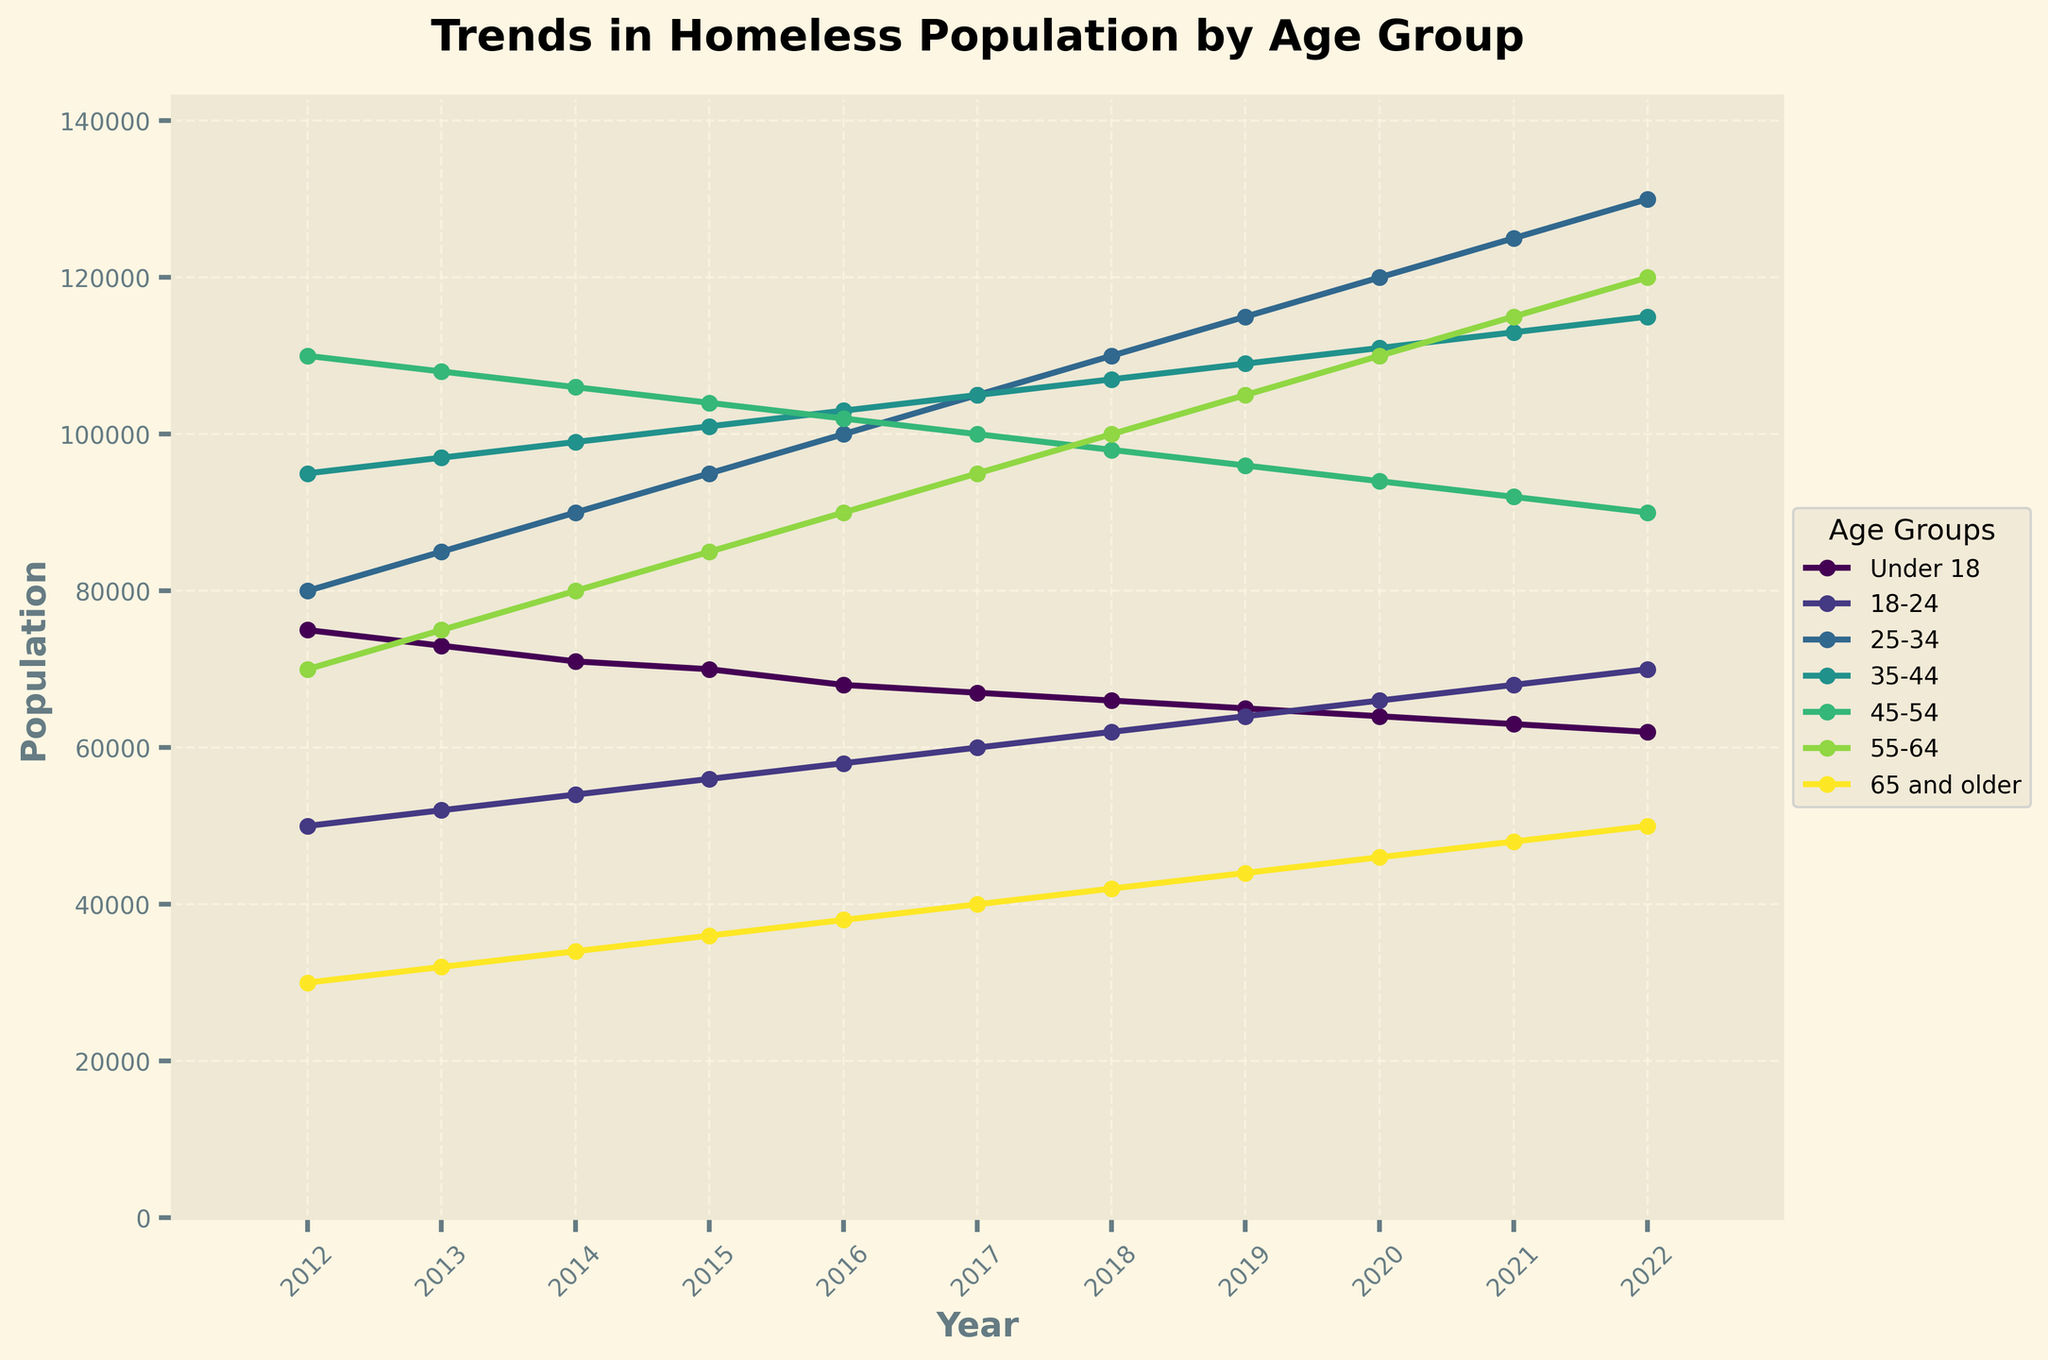What is the general trend in the population of those aged 25-34 over the past decade? The population of those aged 25-34 shows a continuous increase every year. Starting from 80,000 in 2012, it rises annually until it reaches 130,000 in 2022.
Answer: Increasing trend Which age group had the largest initial population in 2012? In 2012, the age group 45-54 had the largest population of 110,000 compared to other age groups.
Answer: 45-54 What is the age group with the highest growth rate from 2012 to 2022? To determine this, calculate the difference for each age group from 2012 to 2022 and spot the highest change. The 25-34 age group increased from 80,000 to 130,000, an increase of 50,000, which is the highest growth among all groups.
Answer: 25-34 Which two age groups crossed each other around 2017? Around the year 2017, the lines representing the populations of age groups 25-34 and 45-54 intersect, indicating they had equal populations of around 105,000.
Answer: 25-34 and 45-54 How did the population of those 65 and older change over the past decade? The population of the 65 and older age group shows a steady increase each year, starting from 30,000 in 2012 to 50,000 in 2022.
Answer: Increasing trend Between which years did the population of those aged 55-64 see the most significant increase? The largest increase for the 55-64 age group occurred between 2018 and 2019, where the population increased from 100,000 to 105,000, a jump of 5,000.
Answer: 2018 to 2019 Which age group showed the most consistent decline over the period? The population of those under 18 consistently declined from 75,000 in 2012 to 62,000 in 2022 without any year showing an increase.
Answer: Under 18 In which year did the gap between the populations of age groups 18-24 and 55-64 first become the smallest? In 2017, the populations of the age groups 18-24 and 55-64 were closest to each other, both with figure reaching 60,000 and 95,000 respectively, reducing the gap.
Answer: 2017 Comparing the year 2015 and 2020, which age groups saw an increase in their population? By comparing the values:
- Under 18: 70,000 to 64,000, decrease
- 18-24: 56,000 to 66,000, increase
- 25-34: 95,000 to 120,000, increase
- 35-44: 101,000 to 111,000, increase
- 45-54: 104,000 to 94,000, decrease
- 55-64: 85,000 to 110,000, increase
- 65 and older: 36,000 to 46,000, increase
Thus, except those under 18 and 45-54, other age groups saw an increase.
Answer: 18-24, 25-34, 35-44, 55-64, 65 and older 